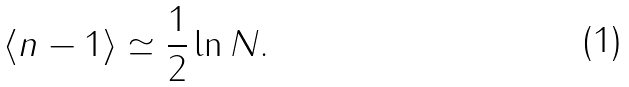Convert formula to latex. <formula><loc_0><loc_0><loc_500><loc_500>\langle n - 1 \rangle \simeq \frac { 1 } { 2 } \ln N .</formula> 